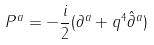<formula> <loc_0><loc_0><loc_500><loc_500>P ^ { a } = - \frac { i } { 2 } ( \partial ^ { a } + q ^ { 4 } \hat { \partial } ^ { a } )</formula> 